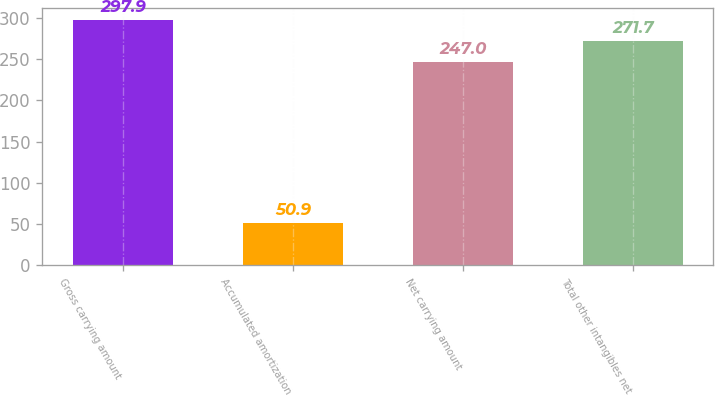Convert chart. <chart><loc_0><loc_0><loc_500><loc_500><bar_chart><fcel>Gross carrying amount<fcel>Accumulated amortization<fcel>Net carrying amount<fcel>Total other intangibles net<nl><fcel>297.9<fcel>50.9<fcel>247<fcel>271.7<nl></chart> 